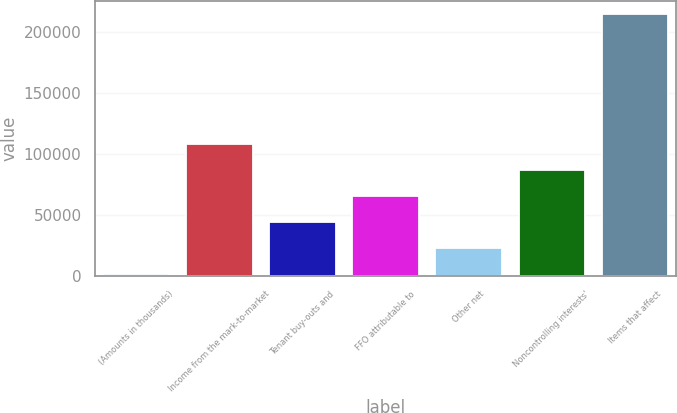Convert chart to OTSL. <chart><loc_0><loc_0><loc_500><loc_500><bar_chart><fcel>(Amounts in thousands)<fcel>Income from the mark-to-market<fcel>Tenant buy-outs and<fcel>FFO attributable to<fcel>Other net<fcel>Noncontrolling interests'<fcel>Items that affect<nl><fcel>2010<fcel>108288<fcel>44521<fcel>65776.5<fcel>23265.5<fcel>87032<fcel>214565<nl></chart> 